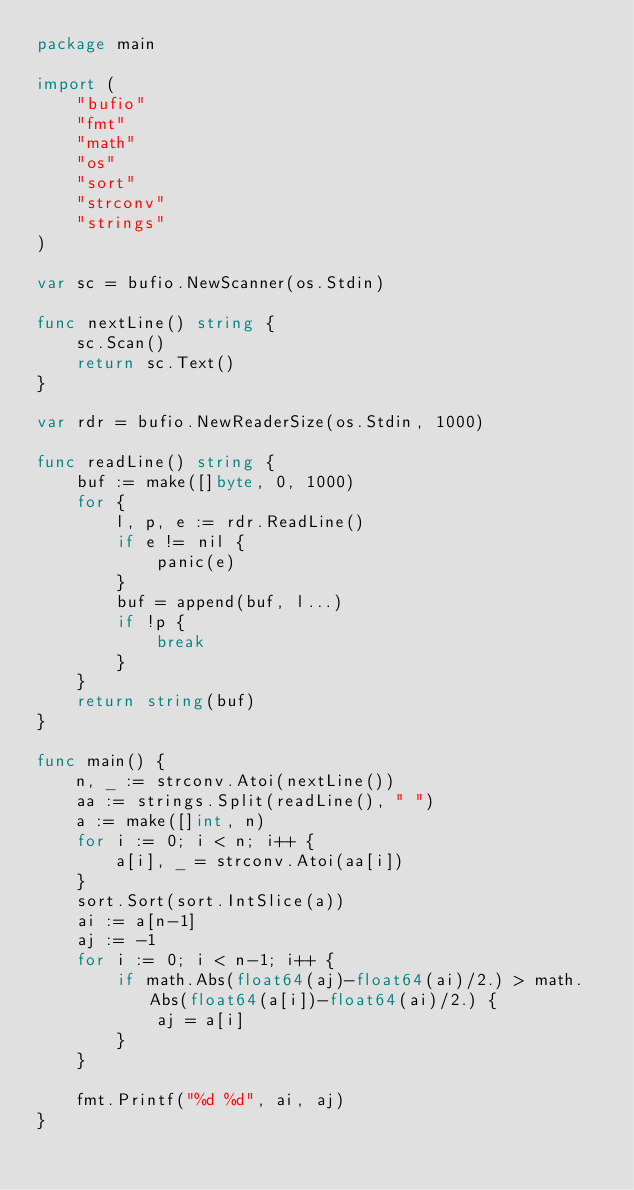Convert code to text. <code><loc_0><loc_0><loc_500><loc_500><_Go_>package main

import (
	"bufio"
	"fmt"
	"math"
	"os"
	"sort"
	"strconv"
	"strings"
)

var sc = bufio.NewScanner(os.Stdin)

func nextLine() string {
	sc.Scan()
	return sc.Text()
}

var rdr = bufio.NewReaderSize(os.Stdin, 1000)

func readLine() string {
	buf := make([]byte, 0, 1000)
	for {
		l, p, e := rdr.ReadLine()
		if e != nil {
			panic(e)
		}
		buf = append(buf, l...)
		if !p {
			break
		}
	}
	return string(buf)
}

func main() {
	n, _ := strconv.Atoi(nextLine())
	aa := strings.Split(readLine(), " ")
	a := make([]int, n)
	for i := 0; i < n; i++ {
		a[i], _ = strconv.Atoi(aa[i])
	}
	sort.Sort(sort.IntSlice(a))
	ai := a[n-1]
	aj := -1
	for i := 0; i < n-1; i++ {
		if math.Abs(float64(aj)-float64(ai)/2.) > math.Abs(float64(a[i])-float64(ai)/2.) {
			aj = a[i]
		}
	}

	fmt.Printf("%d %d", ai, aj)
}
</code> 